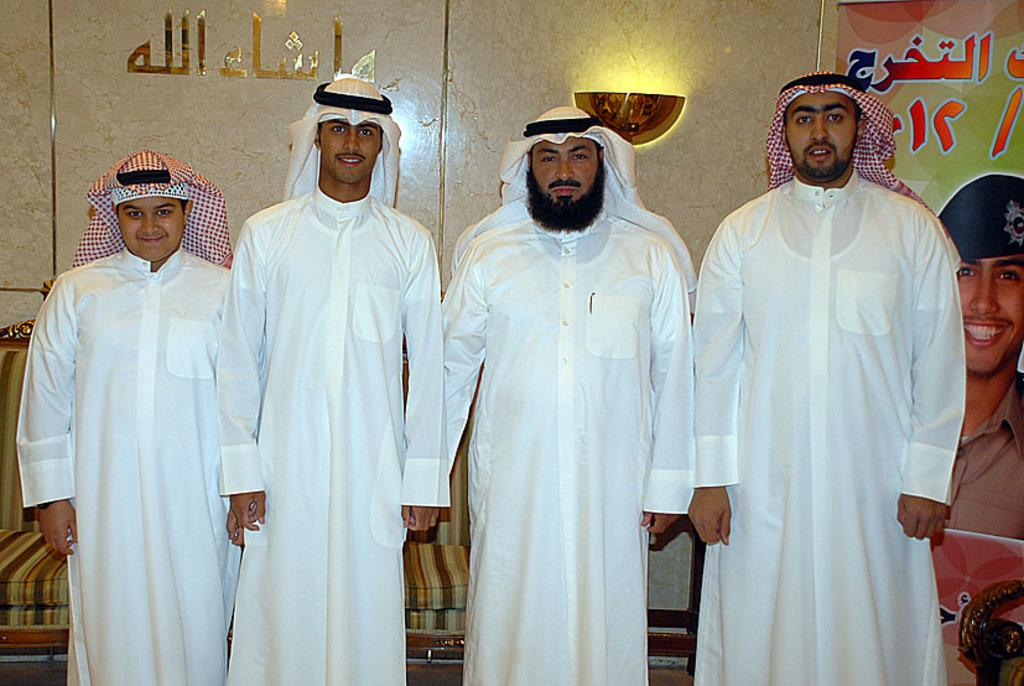How many people are present in the image? There are four people standing in the image. What can be seen on the wall in the background? There is a light on the wall in the background. What is located in the background of the image? There is a hoarding and a couch in the background. What type of stocking is being used to control the behavior of the people in the image? There is no stocking or behavior control mentioned in the image; it simply shows four people standing with a light, hoarding, and couch in the background. 